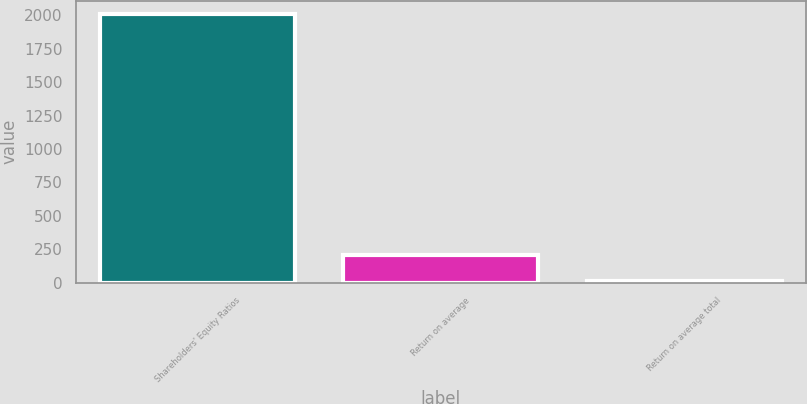Convert chart to OTSL. <chart><loc_0><loc_0><loc_500><loc_500><bar_chart><fcel>Shareholders' Equity Ratios<fcel>Return on average<fcel>Return on average total<nl><fcel>2007<fcel>210.24<fcel>10.6<nl></chart> 